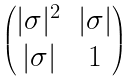<formula> <loc_0><loc_0><loc_500><loc_500>\begin{pmatrix} | \sigma | ^ { 2 } & | \sigma | \\ | \sigma | & 1 \end{pmatrix}</formula> 